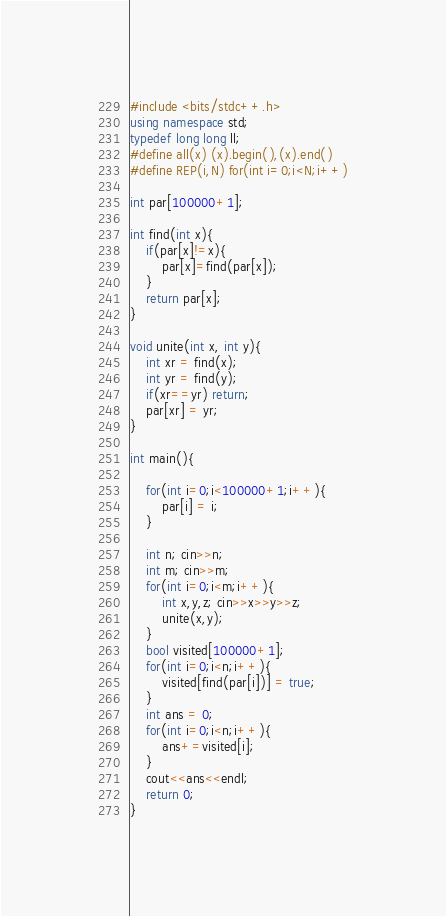Convert code to text. <code><loc_0><loc_0><loc_500><loc_500><_C++_>#include <bits/stdc++.h>
using namespace std;
typedef long long ll;
#define all(x) (x).begin(),(x).end()
#define REP(i,N) for(int i=0;i<N;i++)

int par[100000+1];

int find(int x){
    if(par[x]!=x){
        par[x]=find(par[x]);
    }
    return par[x];
}

void unite(int x, int y){
    int xr = find(x);
    int yr = find(y);
    if(xr==yr) return;
    par[xr] = yr;
}

int main(){

    for(int i=0;i<100000+1;i++){
        par[i] = i;
    }

    int n; cin>>n;
    int m; cin>>m;
    for(int i=0;i<m;i++){
        int x,y,z; cin>>x>>y>>z;
        unite(x,y);
    }
    bool visited[100000+1];
    for(int i=0;i<n;i++){
        visited[find(par[i])] = true;
    }
    int ans = 0;
    for(int i=0;i<n;i++){
        ans+=visited[i];
    }
    cout<<ans<<endl;
    return 0;
}</code> 